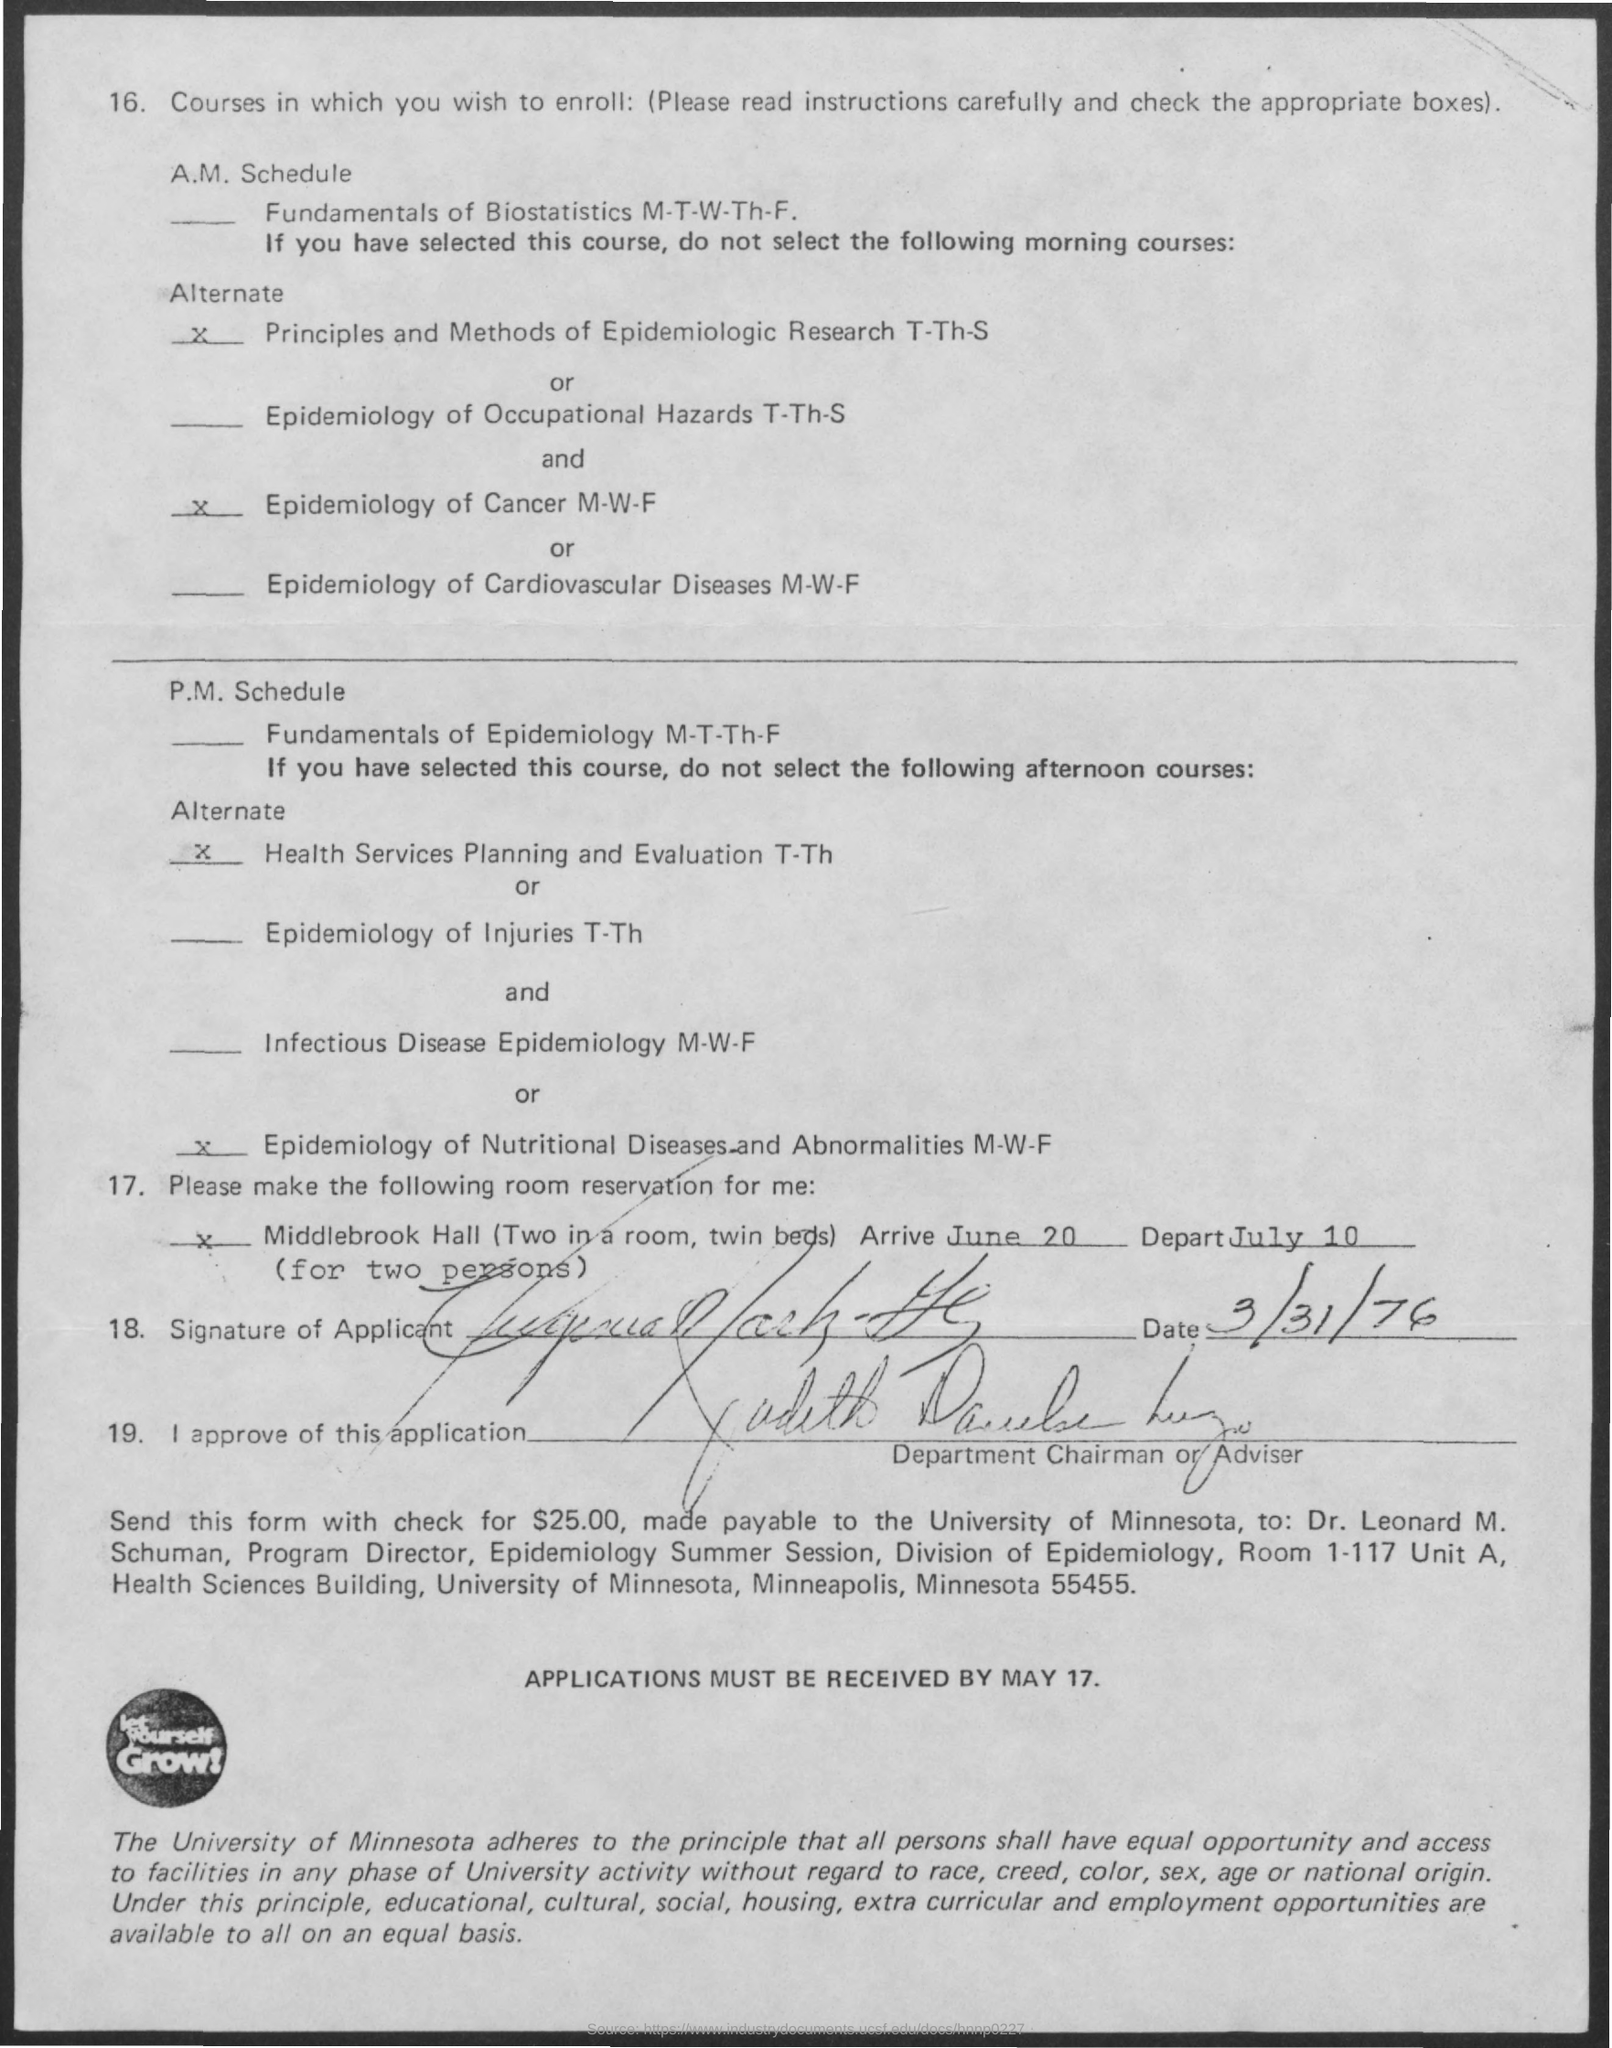Point out several critical features in this image. The arrival date mentioned in the given letter is June 20th. The letter mentions that the "depart date" is on July 10. The signature was done on March 31, 1976. 